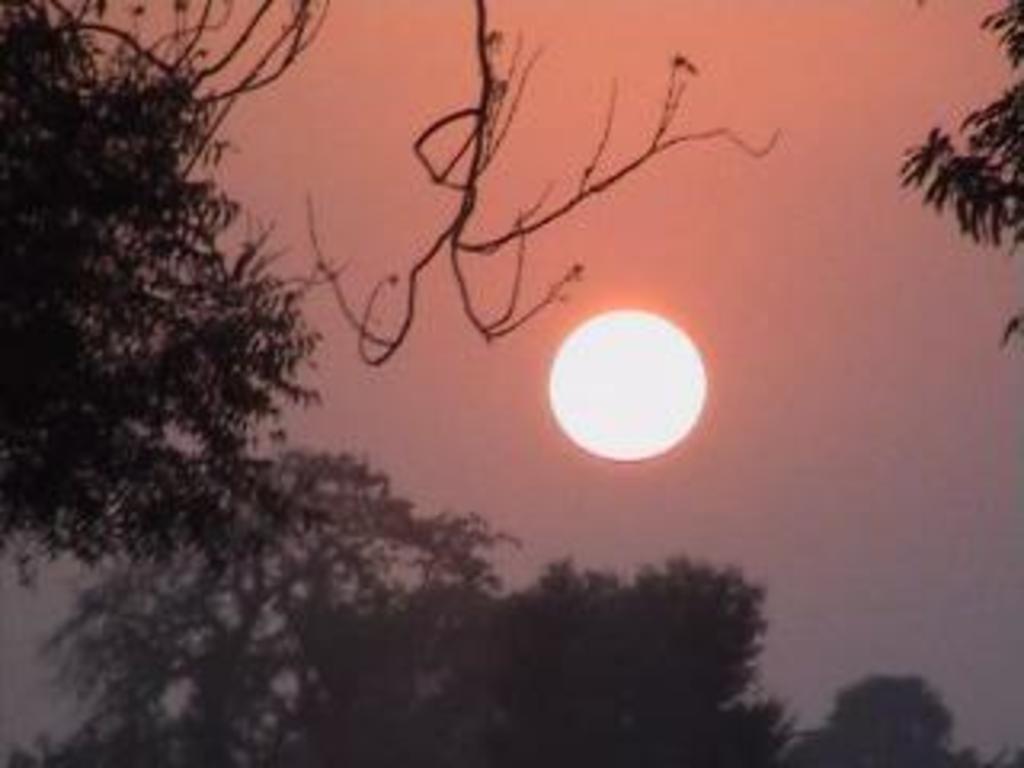Could you give a brief overview of what you see in this image? In this picture we can see trees here, in the background there is sky, we can see the Sun here. 